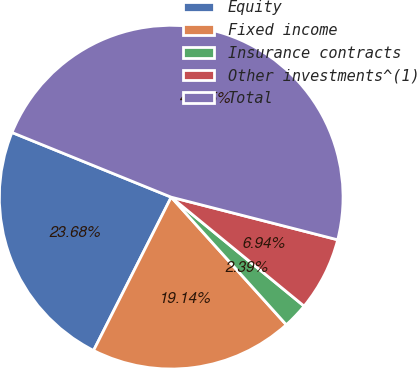<chart> <loc_0><loc_0><loc_500><loc_500><pie_chart><fcel>Equity<fcel>Fixed income<fcel>Insurance contracts<fcel>Other investments^(1)<fcel>Total<nl><fcel>23.68%<fcel>19.14%<fcel>2.39%<fcel>6.94%<fcel>47.85%<nl></chart> 